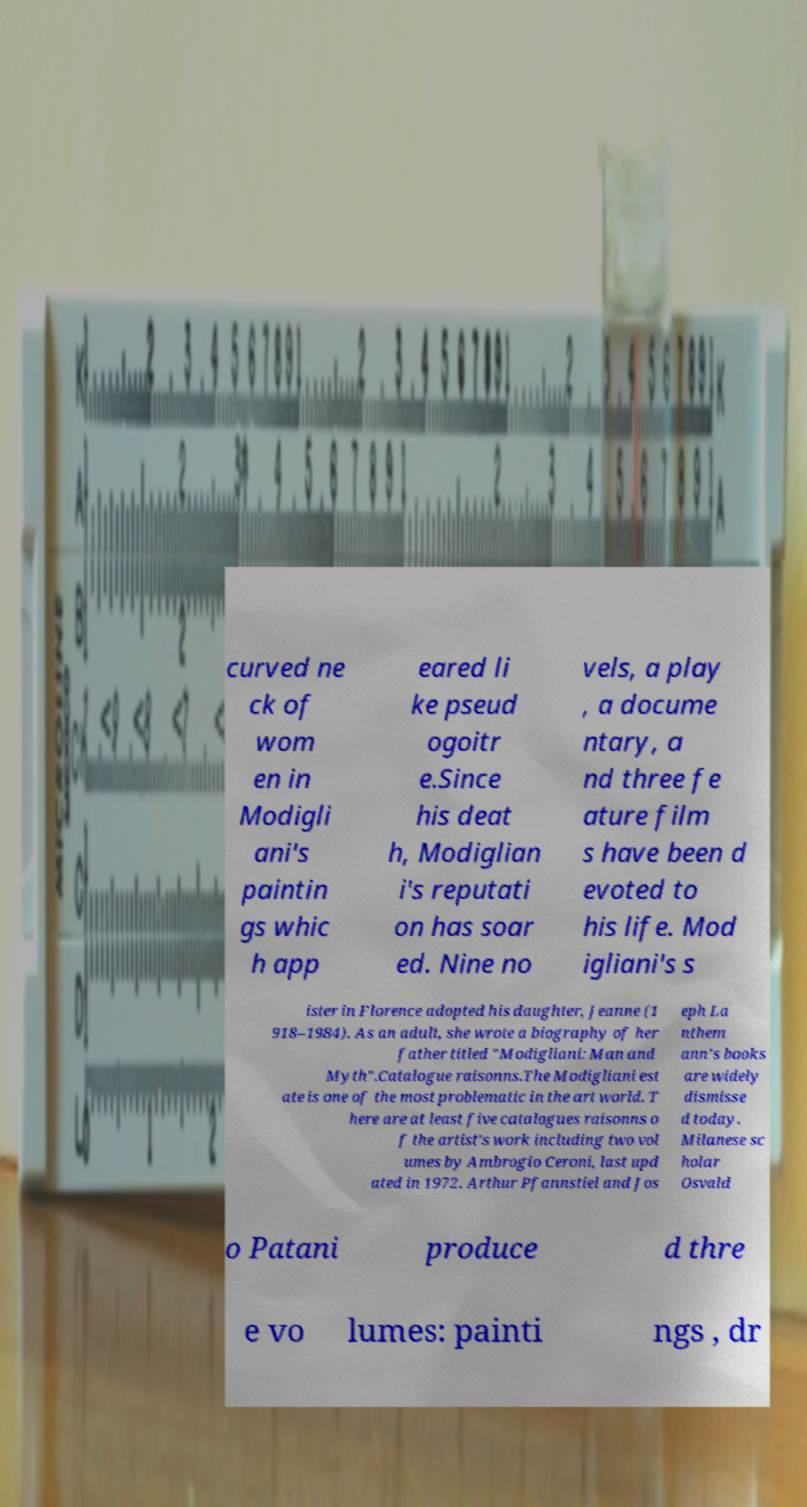Can you read and provide the text displayed in the image?This photo seems to have some interesting text. Can you extract and type it out for me? curved ne ck of wom en in Modigli ani's paintin gs whic h app eared li ke pseud ogoitr e.Since his deat h, Modiglian i's reputati on has soar ed. Nine no vels, a play , a docume ntary, a nd three fe ature film s have been d evoted to his life. Mod igliani's s ister in Florence adopted his daughter, Jeanne (1 918–1984). As an adult, she wrote a biography of her father titled "Modigliani: Man and Myth".Catalogue raisonns.The Modigliani est ate is one of the most problematic in the art world. T here are at least five catalogues raisonns o f the artist's work including two vol umes by Ambrogio Ceroni, last upd ated in 1972. Arthur Pfannstiel and Jos eph La nthem ann's books are widely dismisse d today. Milanese sc holar Osvald o Patani produce d thre e vo lumes: painti ngs , dr 